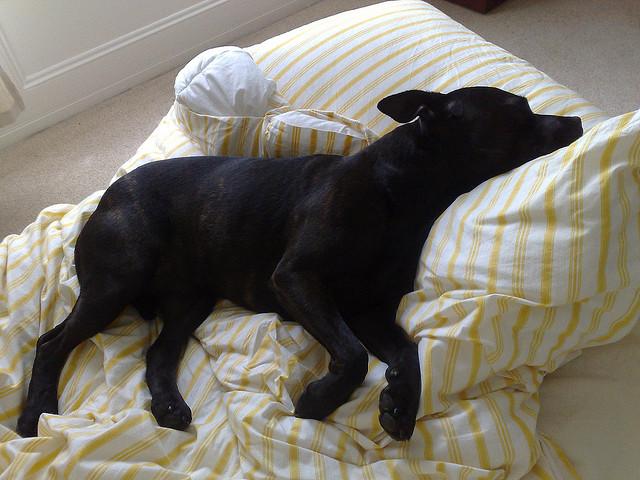Is the dog sleeping on a bed?
Write a very short answer. Yes. Is the pillow coming apart?
Short answer required. Yes. Is the dog playing?
Quick response, please. No. 